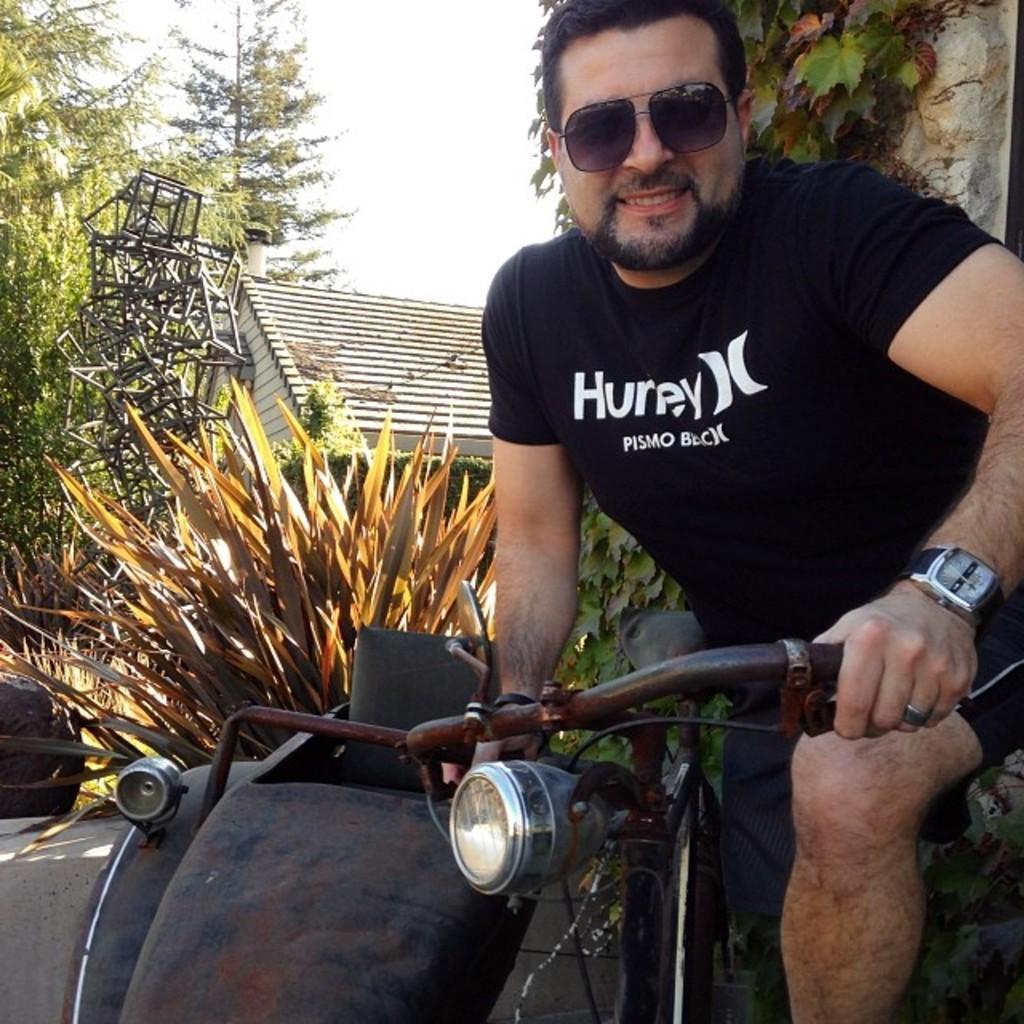How would you summarize this image in a sentence or two? This picture shows a man holding a bicycle in his hand and we see a house and few trees and a plant. 